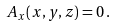Convert formula to latex. <formula><loc_0><loc_0><loc_500><loc_500>A _ { x } ( x , y , z ) = 0 \, .</formula> 